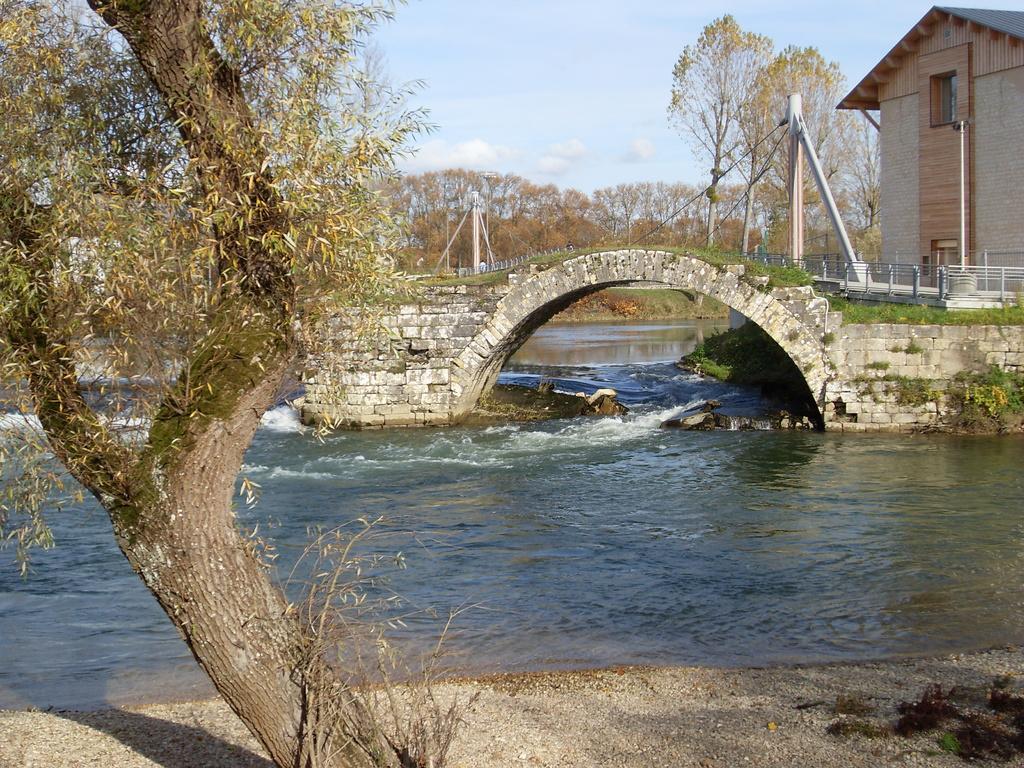Could you give a brief overview of what you see in this image? In this picture we can see a tree on the ground, beside this ground we can see water, bridge, here we can see a house, fence, trees, grass, poles and we can see sky in the background. 